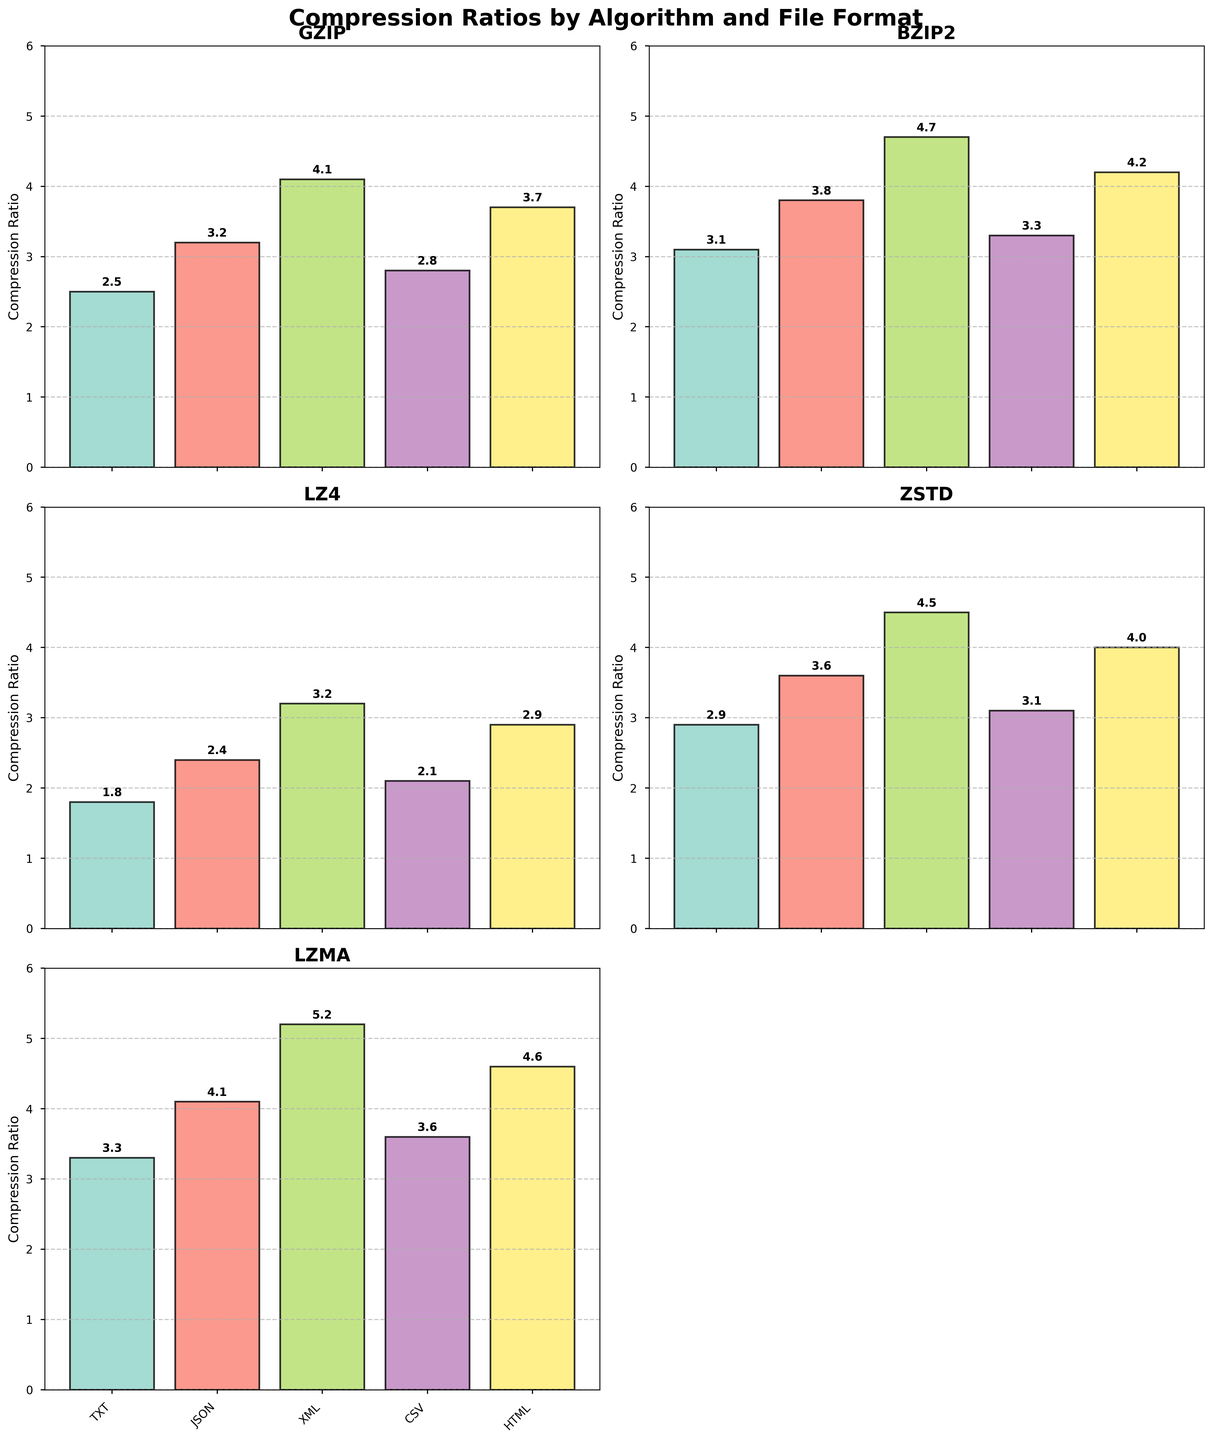Which algorithm has the highest compression ratio for TXT files? Look at the bar heights for TXT files across the different algorithms. The LZMA algorithm has the highest bar height for TXT files.
Answer: LZMA Which file format achieves the best compression ratio with the GZIP algorithm? Refer to the heights of the bars corresponding to the GZIP algorithm. The XML format has the tallest bar, indicating the highest compression ratio.
Answer: XML Compare the compression ratios of GZIP and BZIP2 for JSON files. Which one is greater? Check the bar heights for JSON files under both GZIP and BZIP2. The BZIP2 algorithm has a taller bar than the GZIP algorithm for JSON files.
Answer: BZIP2 What is the average compression ratio for the HTML format across all algorithms? Sum the compression ratios for HTML in different algorithms (3.7 + 4.2 + 2.9 + 4.0 + 4.6 = 19.4) and divide by the number of algorithms (5).
Answer: 3.88 For the CSV format, which algorithm has the lowest compression ratio? Examine the bars corresponding to the CSV format across all algorithms. The LZ4 algorithm has the lowest bar, indicating the lowest compression ratio for CSV files.
Answer: LZ4 Is the compression ratio for XML files using ZSTD greater than 4? Look at the bar height for ZSTD with XML files. The bar is above the 4 mark.
Answer: Yes Does the LZMA algorithm outperform the ZSTD algorithm in compressing JSON files? Compare the bar heights for JSON under the LZMA and ZSTD algorithms. The LZMA bar is taller, indicating a better compression ratio.
Answer: Yes Which algorithm shows the most consistent compression ratios across the different formats? Compare the heights of the bars within each subplot to see which algorithm has similar heights across all formats. The LZ4 algorithm shows the most consistent compression ratios.
Answer: LZ4 Calculate the range of compression ratios for the BZIP2 algorithm. Identify the maximum and minimum compression ratios for BZIP2 (4.7 for XML and 3.1 for TXT), then find the difference: 4.7 - 3.1.
Answer: 1.6 Which file format has the widest range in compression ratios across all algorithms? Calculate the range for each format:
- TXT: 3.3 - 1.8 = 1.5
- JSON: 4.1 - 2.4 = 1.7
- XML: 5.2 - 3.2 = 2.0
- CSV: 3.6 - 2.1 = 1.5
- HTML: 4.6 - 2.9 = 1.7
The XML format has the widest range.
Answer: XML 